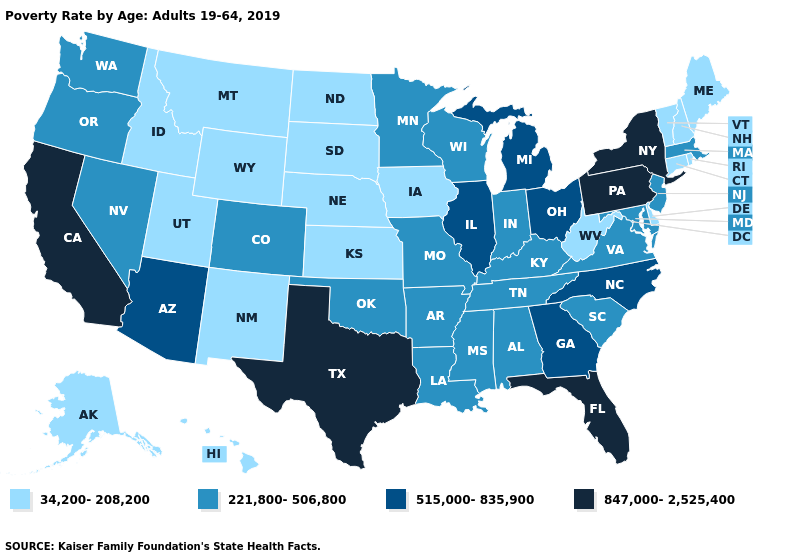Which states have the lowest value in the MidWest?
Write a very short answer. Iowa, Kansas, Nebraska, North Dakota, South Dakota. What is the lowest value in states that border Oklahoma?
Quick response, please. 34,200-208,200. Name the states that have a value in the range 847,000-2,525,400?
Short answer required. California, Florida, New York, Pennsylvania, Texas. Does Pennsylvania have the same value as California?
Short answer required. Yes. Does Texas have the highest value in the USA?
Be succinct. Yes. What is the lowest value in states that border West Virginia?
Be succinct. 221,800-506,800. Name the states that have a value in the range 515,000-835,900?
Answer briefly. Arizona, Georgia, Illinois, Michigan, North Carolina, Ohio. Does New York have the highest value in the USA?
Keep it brief. Yes. Name the states that have a value in the range 34,200-208,200?
Give a very brief answer. Alaska, Connecticut, Delaware, Hawaii, Idaho, Iowa, Kansas, Maine, Montana, Nebraska, New Hampshire, New Mexico, North Dakota, Rhode Island, South Dakota, Utah, Vermont, West Virginia, Wyoming. What is the value of Georgia?
Short answer required. 515,000-835,900. Does Texas have the highest value in the USA?
Give a very brief answer. Yes. Does the first symbol in the legend represent the smallest category?
Give a very brief answer. Yes. What is the highest value in the West ?
Write a very short answer. 847,000-2,525,400. What is the highest value in the USA?
Short answer required. 847,000-2,525,400. Does Oklahoma have the highest value in the South?
Short answer required. No. 